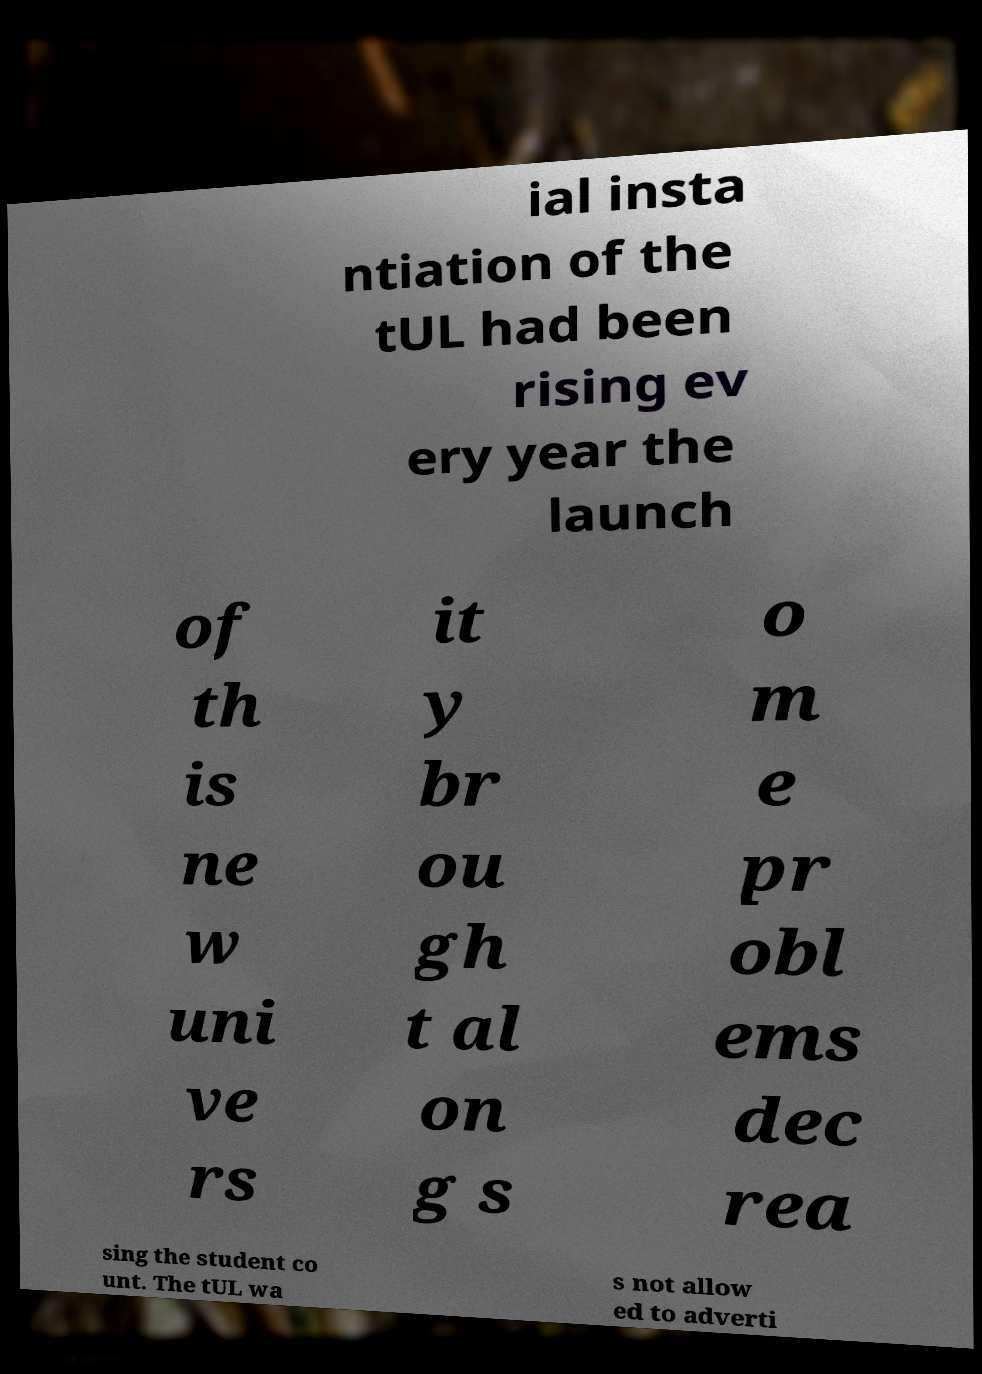I need the written content from this picture converted into text. Can you do that? ial insta ntiation of the tUL had been rising ev ery year the launch of th is ne w uni ve rs it y br ou gh t al on g s o m e pr obl ems dec rea sing the student co unt. The tUL wa s not allow ed to adverti 